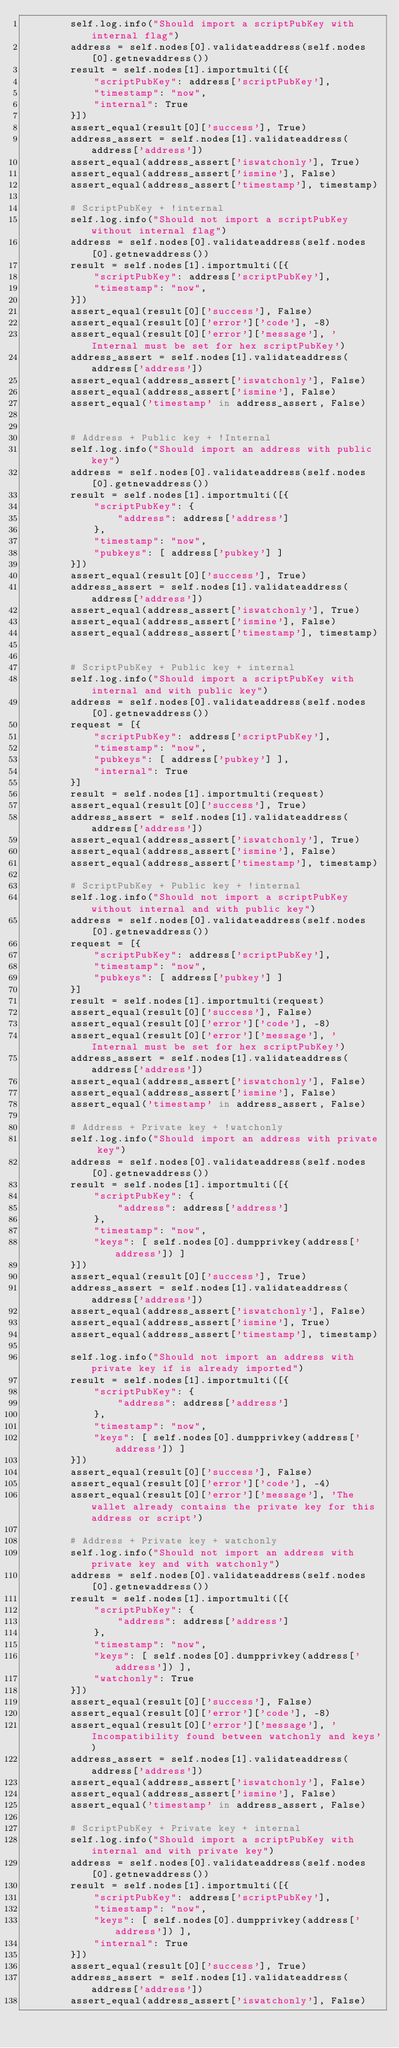Convert code to text. <code><loc_0><loc_0><loc_500><loc_500><_Python_>        self.log.info("Should import a scriptPubKey with internal flag")
        address = self.nodes[0].validateaddress(self.nodes[0].getnewaddress())
        result = self.nodes[1].importmulti([{
            "scriptPubKey": address['scriptPubKey'],
            "timestamp": "now",
            "internal": True
        }])
        assert_equal(result[0]['success'], True)
        address_assert = self.nodes[1].validateaddress(address['address'])
        assert_equal(address_assert['iswatchonly'], True)
        assert_equal(address_assert['ismine'], False)
        assert_equal(address_assert['timestamp'], timestamp)

        # ScriptPubKey + !internal
        self.log.info("Should not import a scriptPubKey without internal flag")
        address = self.nodes[0].validateaddress(self.nodes[0].getnewaddress())
        result = self.nodes[1].importmulti([{
            "scriptPubKey": address['scriptPubKey'],
            "timestamp": "now",
        }])
        assert_equal(result[0]['success'], False)
        assert_equal(result[0]['error']['code'], -8)
        assert_equal(result[0]['error']['message'], 'Internal must be set for hex scriptPubKey')
        address_assert = self.nodes[1].validateaddress(address['address'])
        assert_equal(address_assert['iswatchonly'], False)
        assert_equal(address_assert['ismine'], False)
        assert_equal('timestamp' in address_assert, False)


        # Address + Public key + !Internal
        self.log.info("Should import an address with public key")
        address = self.nodes[0].validateaddress(self.nodes[0].getnewaddress())
        result = self.nodes[1].importmulti([{
            "scriptPubKey": {
                "address": address['address']
            },
            "timestamp": "now",
            "pubkeys": [ address['pubkey'] ]
        }])
        assert_equal(result[0]['success'], True)
        address_assert = self.nodes[1].validateaddress(address['address'])
        assert_equal(address_assert['iswatchonly'], True)
        assert_equal(address_assert['ismine'], False)
        assert_equal(address_assert['timestamp'], timestamp)


        # ScriptPubKey + Public key + internal
        self.log.info("Should import a scriptPubKey with internal and with public key")
        address = self.nodes[0].validateaddress(self.nodes[0].getnewaddress())
        request = [{
            "scriptPubKey": address['scriptPubKey'],
            "timestamp": "now",
            "pubkeys": [ address['pubkey'] ],
            "internal": True
        }]
        result = self.nodes[1].importmulti(request)
        assert_equal(result[0]['success'], True)
        address_assert = self.nodes[1].validateaddress(address['address'])
        assert_equal(address_assert['iswatchonly'], True)
        assert_equal(address_assert['ismine'], False)
        assert_equal(address_assert['timestamp'], timestamp)

        # ScriptPubKey + Public key + !internal
        self.log.info("Should not import a scriptPubKey without internal and with public key")
        address = self.nodes[0].validateaddress(self.nodes[0].getnewaddress())
        request = [{
            "scriptPubKey": address['scriptPubKey'],
            "timestamp": "now",
            "pubkeys": [ address['pubkey'] ]
        }]
        result = self.nodes[1].importmulti(request)
        assert_equal(result[0]['success'], False)
        assert_equal(result[0]['error']['code'], -8)
        assert_equal(result[0]['error']['message'], 'Internal must be set for hex scriptPubKey')
        address_assert = self.nodes[1].validateaddress(address['address'])
        assert_equal(address_assert['iswatchonly'], False)
        assert_equal(address_assert['ismine'], False)
        assert_equal('timestamp' in address_assert, False)

        # Address + Private key + !watchonly
        self.log.info("Should import an address with private key")
        address = self.nodes[0].validateaddress(self.nodes[0].getnewaddress())
        result = self.nodes[1].importmulti([{
            "scriptPubKey": {
                "address": address['address']
            },
            "timestamp": "now",
            "keys": [ self.nodes[0].dumpprivkey(address['address']) ]
        }])
        assert_equal(result[0]['success'], True)
        address_assert = self.nodes[1].validateaddress(address['address'])
        assert_equal(address_assert['iswatchonly'], False)
        assert_equal(address_assert['ismine'], True)
        assert_equal(address_assert['timestamp'], timestamp)

        self.log.info("Should not import an address with private key if is already imported")
        result = self.nodes[1].importmulti([{
            "scriptPubKey": {
                "address": address['address']
            },
            "timestamp": "now",
            "keys": [ self.nodes[0].dumpprivkey(address['address']) ]
        }])
        assert_equal(result[0]['success'], False)
        assert_equal(result[0]['error']['code'], -4)
        assert_equal(result[0]['error']['message'], 'The wallet already contains the private key for this address or script')

        # Address + Private key + watchonly
        self.log.info("Should not import an address with private key and with watchonly")
        address = self.nodes[0].validateaddress(self.nodes[0].getnewaddress())
        result = self.nodes[1].importmulti([{
            "scriptPubKey": {
                "address": address['address']
            },
            "timestamp": "now",
            "keys": [ self.nodes[0].dumpprivkey(address['address']) ],
            "watchonly": True
        }])
        assert_equal(result[0]['success'], False)
        assert_equal(result[0]['error']['code'], -8)
        assert_equal(result[0]['error']['message'], 'Incompatibility found between watchonly and keys')
        address_assert = self.nodes[1].validateaddress(address['address'])
        assert_equal(address_assert['iswatchonly'], False)
        assert_equal(address_assert['ismine'], False)
        assert_equal('timestamp' in address_assert, False)

        # ScriptPubKey + Private key + internal
        self.log.info("Should import a scriptPubKey with internal and with private key")
        address = self.nodes[0].validateaddress(self.nodes[0].getnewaddress())
        result = self.nodes[1].importmulti([{
            "scriptPubKey": address['scriptPubKey'],
            "timestamp": "now",
            "keys": [ self.nodes[0].dumpprivkey(address['address']) ],
            "internal": True
        }])
        assert_equal(result[0]['success'], True)
        address_assert = self.nodes[1].validateaddress(address['address'])
        assert_equal(address_assert['iswatchonly'], False)</code> 